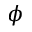Convert formula to latex. <formula><loc_0><loc_0><loc_500><loc_500>\phi</formula> 